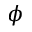Convert formula to latex. <formula><loc_0><loc_0><loc_500><loc_500>\phi</formula> 